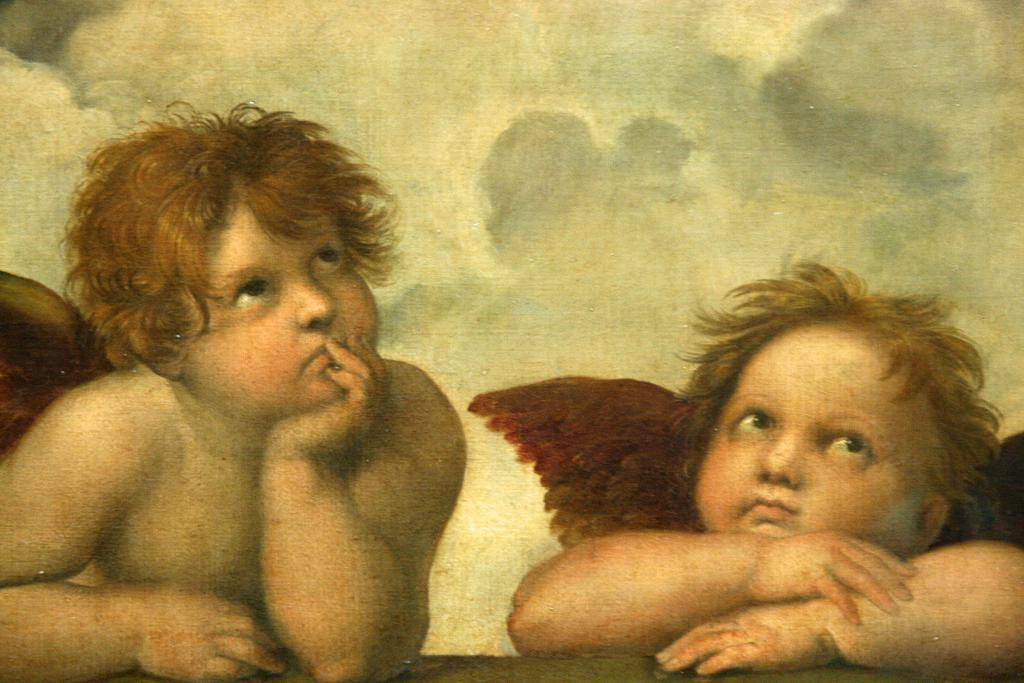What is the main subject of the image? There is a painting in the image. What is depicted in the painting? The painting depicts two babies with wings. What can be seen in the background of the painting? There is sky visible in the background of the painting. What is present in the sky? Clouds are present in the sky. How many parents are visible in the painting? There are no parents depicted in the painting; it features two babies with wings. What type of animal can be seen grazing in the background of the painting? There are no animals present in the painting; it depicts a sky with clouds. 